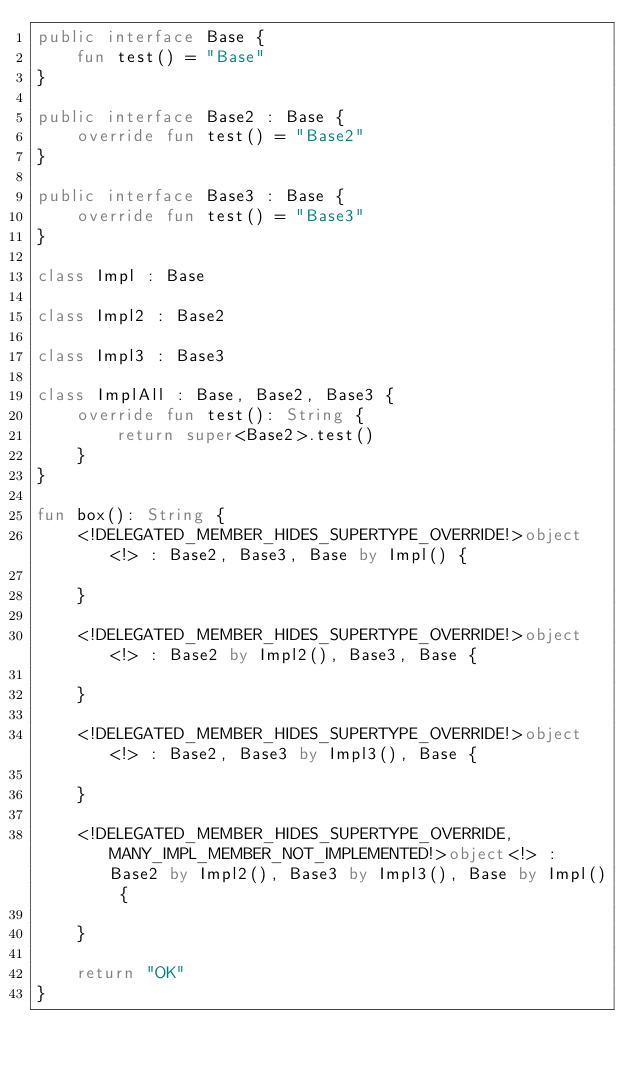Convert code to text. <code><loc_0><loc_0><loc_500><loc_500><_Kotlin_>public interface Base {
    fun test() = "Base"
}

public interface Base2 : Base {
    override fun test() = "Base2"
}

public interface Base3 : Base {
    override fun test() = "Base3"
}

class Impl : Base

class Impl2 : Base2

class Impl3 : Base3

class ImplAll : Base, Base2, Base3 {
    override fun test(): String {
        return super<Base2>.test()
    }
}

fun box(): String {
    <!DELEGATED_MEMBER_HIDES_SUPERTYPE_OVERRIDE!>object<!> : Base2, Base3, Base by Impl() {

    }

    <!DELEGATED_MEMBER_HIDES_SUPERTYPE_OVERRIDE!>object<!> : Base2 by Impl2(), Base3, Base {

    }

    <!DELEGATED_MEMBER_HIDES_SUPERTYPE_OVERRIDE!>object<!> : Base2, Base3 by Impl3(), Base {

    }

    <!DELEGATED_MEMBER_HIDES_SUPERTYPE_OVERRIDE, MANY_IMPL_MEMBER_NOT_IMPLEMENTED!>object<!> : Base2 by Impl2(), Base3 by Impl3(), Base by Impl() {

    }

    return "OK"
}
</code> 